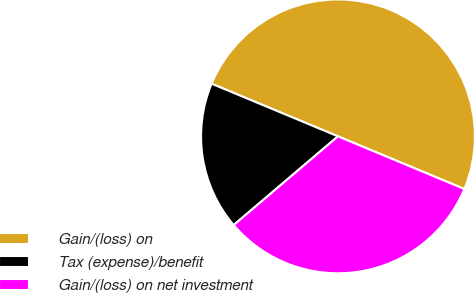Convert chart. <chart><loc_0><loc_0><loc_500><loc_500><pie_chart><fcel>Gain/(loss) on<fcel>Tax (expense)/benefit<fcel>Gain/(loss) on net investment<nl><fcel>50.0%<fcel>17.5%<fcel>32.5%<nl></chart> 